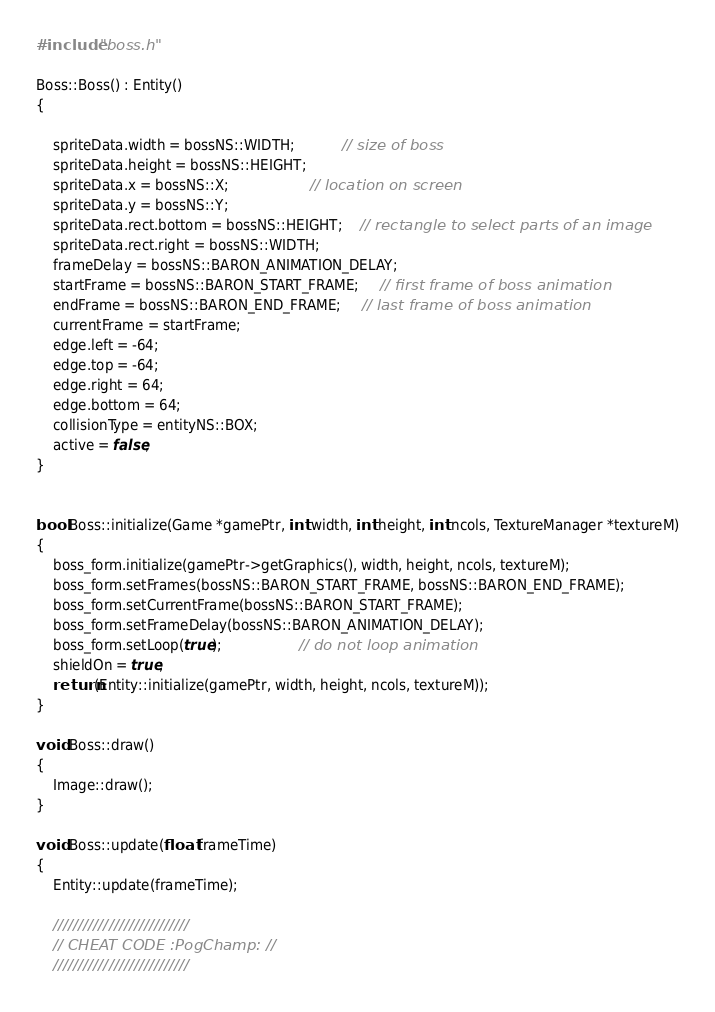<code> <loc_0><loc_0><loc_500><loc_500><_C++_>#include "boss.h"

Boss::Boss() : Entity()
{

	spriteData.width = bossNS::WIDTH;           // size of boss
	spriteData.height = bossNS::HEIGHT;
	spriteData.x = bossNS::X;                   // location on screen
	spriteData.y = bossNS::Y;
	spriteData.rect.bottom = bossNS::HEIGHT;    // rectangle to select parts of an image
	spriteData.rect.right = bossNS::WIDTH;
	frameDelay = bossNS::BARON_ANIMATION_DELAY;
	startFrame = bossNS::BARON_START_FRAME;     // first frame of boss animation
	endFrame = bossNS::BARON_END_FRAME;     // last frame of boss animation
	currentFrame = startFrame;
	edge.left = -64;
	edge.top = -64;
	edge.right = 64;
	edge.bottom = 64;
	collisionType = entityNS::BOX;
	active = false;
}


bool Boss::initialize(Game *gamePtr, int width, int height, int ncols, TextureManager *textureM)
{
	boss_form.initialize(gamePtr->getGraphics(), width, height, ncols, textureM);
	boss_form.setFrames(bossNS::BARON_START_FRAME, bossNS::BARON_END_FRAME);
	boss_form.setCurrentFrame(bossNS::BARON_START_FRAME);
	boss_form.setFrameDelay(bossNS::BARON_ANIMATION_DELAY);
	boss_form.setLoop(true);                  // do not loop animation
	shieldOn = true;
	return(Entity::initialize(gamePtr, width, height, ncols, textureM));
}

void Boss::draw()
{
	Image::draw();
}

void Boss::update(float frameTime)
{
	Entity::update(frameTime);
	
	///////////////////////////
	// CHEAT CODE :PogChamp: //
	///////////////////////////</code> 